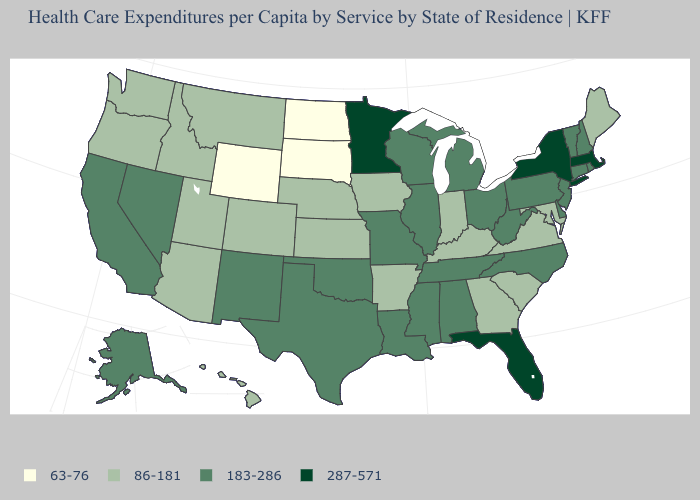What is the value of West Virginia?
Concise answer only. 183-286. Among the states that border Illinois , which have the highest value?
Write a very short answer. Missouri, Wisconsin. Is the legend a continuous bar?
Keep it brief. No. What is the value of Nebraska?
Concise answer only. 86-181. What is the value of Colorado?
Concise answer only. 86-181. What is the value of Georgia?
Give a very brief answer. 86-181. Name the states that have a value in the range 63-76?
Write a very short answer. North Dakota, South Dakota, Wyoming. Name the states that have a value in the range 86-181?
Give a very brief answer. Arizona, Arkansas, Colorado, Georgia, Hawaii, Idaho, Indiana, Iowa, Kansas, Kentucky, Maine, Maryland, Montana, Nebraska, Oregon, South Carolina, Utah, Virginia, Washington. What is the value of Mississippi?
Short answer required. 183-286. Does Maine have the lowest value in the Northeast?
Give a very brief answer. Yes. What is the value of Montana?
Give a very brief answer. 86-181. Name the states that have a value in the range 183-286?
Quick response, please. Alabama, Alaska, California, Connecticut, Delaware, Illinois, Louisiana, Michigan, Mississippi, Missouri, Nevada, New Hampshire, New Jersey, New Mexico, North Carolina, Ohio, Oklahoma, Pennsylvania, Rhode Island, Tennessee, Texas, Vermont, West Virginia, Wisconsin. What is the highest value in states that border Indiana?
Be succinct. 183-286. What is the value of North Carolina?
Short answer required. 183-286. Name the states that have a value in the range 183-286?
Concise answer only. Alabama, Alaska, California, Connecticut, Delaware, Illinois, Louisiana, Michigan, Mississippi, Missouri, Nevada, New Hampshire, New Jersey, New Mexico, North Carolina, Ohio, Oklahoma, Pennsylvania, Rhode Island, Tennessee, Texas, Vermont, West Virginia, Wisconsin. 